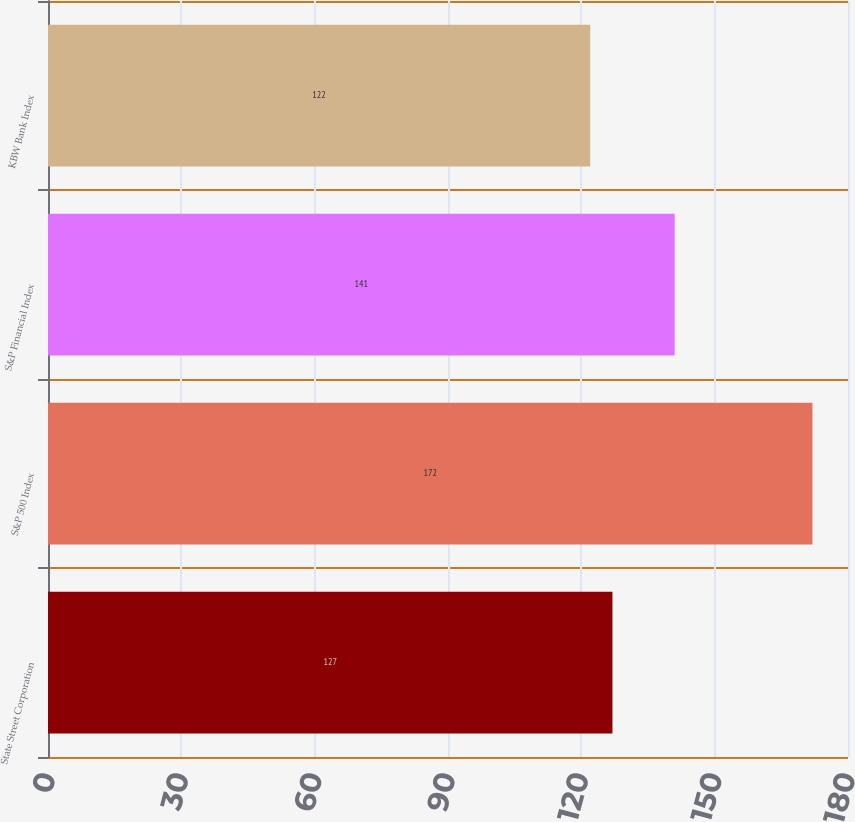Convert chart. <chart><loc_0><loc_0><loc_500><loc_500><bar_chart><fcel>State Street Corporation<fcel>S&P 500 Index<fcel>S&P Financial Index<fcel>KBW Bank Index<nl><fcel>127<fcel>172<fcel>141<fcel>122<nl></chart> 